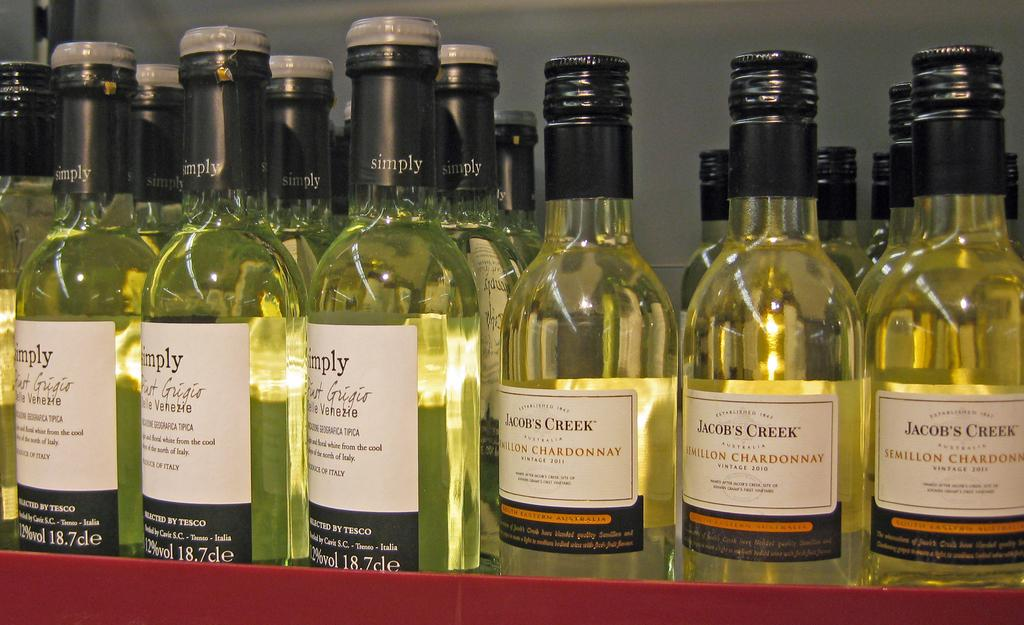Provide a one-sentence caption for the provided image. Jacob's creek is well known for its bottle's of Chardonnay wine. 